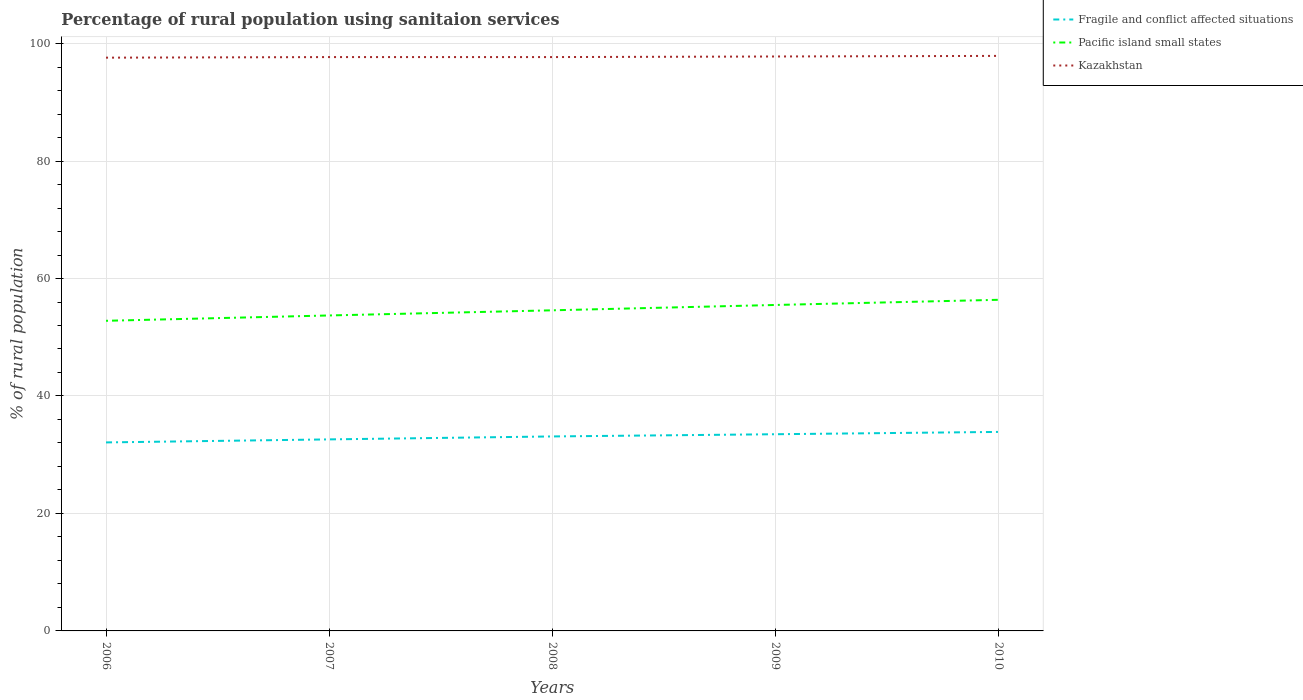Does the line corresponding to Pacific island small states intersect with the line corresponding to Fragile and conflict affected situations?
Keep it short and to the point. No. Is the number of lines equal to the number of legend labels?
Give a very brief answer. Yes. Across all years, what is the maximum percentage of rural population using sanitaion services in Kazakhstan?
Your answer should be compact. 97.6. In which year was the percentage of rural population using sanitaion services in Pacific island small states maximum?
Your response must be concise. 2006. What is the total percentage of rural population using sanitaion services in Fragile and conflict affected situations in the graph?
Provide a short and direct response. -0.5. What is the difference between the highest and the second highest percentage of rural population using sanitaion services in Fragile and conflict affected situations?
Your answer should be compact. 1.79. Is the percentage of rural population using sanitaion services in Fragile and conflict affected situations strictly greater than the percentage of rural population using sanitaion services in Kazakhstan over the years?
Ensure brevity in your answer.  Yes. What is the difference between two consecutive major ticks on the Y-axis?
Offer a terse response. 20. How many legend labels are there?
Make the answer very short. 3. What is the title of the graph?
Offer a very short reply. Percentage of rural population using sanitaion services. What is the label or title of the X-axis?
Your answer should be very brief. Years. What is the label or title of the Y-axis?
Offer a terse response. % of rural population. What is the % of rural population of Fragile and conflict affected situations in 2006?
Offer a terse response. 32.09. What is the % of rural population of Pacific island small states in 2006?
Offer a terse response. 52.8. What is the % of rural population of Kazakhstan in 2006?
Give a very brief answer. 97.6. What is the % of rural population in Fragile and conflict affected situations in 2007?
Ensure brevity in your answer.  32.61. What is the % of rural population of Pacific island small states in 2007?
Offer a very short reply. 53.71. What is the % of rural population of Kazakhstan in 2007?
Ensure brevity in your answer.  97.7. What is the % of rural population in Fragile and conflict affected situations in 2008?
Keep it short and to the point. 33.11. What is the % of rural population in Pacific island small states in 2008?
Provide a short and direct response. 54.59. What is the % of rural population in Kazakhstan in 2008?
Your answer should be very brief. 97.7. What is the % of rural population of Fragile and conflict affected situations in 2009?
Offer a terse response. 33.49. What is the % of rural population of Pacific island small states in 2009?
Ensure brevity in your answer.  55.5. What is the % of rural population of Kazakhstan in 2009?
Make the answer very short. 97.8. What is the % of rural population in Fragile and conflict affected situations in 2010?
Offer a very short reply. 33.88. What is the % of rural population of Pacific island small states in 2010?
Provide a short and direct response. 56.37. What is the % of rural population in Kazakhstan in 2010?
Provide a succinct answer. 97.9. Across all years, what is the maximum % of rural population in Fragile and conflict affected situations?
Ensure brevity in your answer.  33.88. Across all years, what is the maximum % of rural population in Pacific island small states?
Provide a succinct answer. 56.37. Across all years, what is the maximum % of rural population in Kazakhstan?
Make the answer very short. 97.9. Across all years, what is the minimum % of rural population of Fragile and conflict affected situations?
Your response must be concise. 32.09. Across all years, what is the minimum % of rural population of Pacific island small states?
Ensure brevity in your answer.  52.8. Across all years, what is the minimum % of rural population of Kazakhstan?
Provide a short and direct response. 97.6. What is the total % of rural population in Fragile and conflict affected situations in the graph?
Offer a very short reply. 165.19. What is the total % of rural population in Pacific island small states in the graph?
Your answer should be compact. 272.97. What is the total % of rural population in Kazakhstan in the graph?
Your answer should be compact. 488.7. What is the difference between the % of rural population in Fragile and conflict affected situations in 2006 and that in 2007?
Provide a short and direct response. -0.51. What is the difference between the % of rural population in Pacific island small states in 2006 and that in 2007?
Provide a short and direct response. -0.91. What is the difference between the % of rural population of Kazakhstan in 2006 and that in 2007?
Your response must be concise. -0.1. What is the difference between the % of rural population in Fragile and conflict affected situations in 2006 and that in 2008?
Your answer should be very brief. -1.02. What is the difference between the % of rural population in Pacific island small states in 2006 and that in 2008?
Give a very brief answer. -1.78. What is the difference between the % of rural population of Fragile and conflict affected situations in 2006 and that in 2009?
Your response must be concise. -1.39. What is the difference between the % of rural population in Pacific island small states in 2006 and that in 2009?
Keep it short and to the point. -2.69. What is the difference between the % of rural population in Fragile and conflict affected situations in 2006 and that in 2010?
Ensure brevity in your answer.  -1.79. What is the difference between the % of rural population in Pacific island small states in 2006 and that in 2010?
Your response must be concise. -3.57. What is the difference between the % of rural population of Fragile and conflict affected situations in 2007 and that in 2008?
Keep it short and to the point. -0.5. What is the difference between the % of rural population of Pacific island small states in 2007 and that in 2008?
Your response must be concise. -0.88. What is the difference between the % of rural population of Kazakhstan in 2007 and that in 2008?
Ensure brevity in your answer.  0. What is the difference between the % of rural population of Fragile and conflict affected situations in 2007 and that in 2009?
Provide a short and direct response. -0.88. What is the difference between the % of rural population in Pacific island small states in 2007 and that in 2009?
Offer a terse response. -1.79. What is the difference between the % of rural population in Fragile and conflict affected situations in 2007 and that in 2010?
Ensure brevity in your answer.  -1.27. What is the difference between the % of rural population of Pacific island small states in 2007 and that in 2010?
Provide a succinct answer. -2.67. What is the difference between the % of rural population of Fragile and conflict affected situations in 2008 and that in 2009?
Give a very brief answer. -0.38. What is the difference between the % of rural population of Pacific island small states in 2008 and that in 2009?
Ensure brevity in your answer.  -0.91. What is the difference between the % of rural population in Fragile and conflict affected situations in 2008 and that in 2010?
Provide a short and direct response. -0.77. What is the difference between the % of rural population of Pacific island small states in 2008 and that in 2010?
Offer a terse response. -1.79. What is the difference between the % of rural population of Kazakhstan in 2008 and that in 2010?
Provide a short and direct response. -0.2. What is the difference between the % of rural population in Fragile and conflict affected situations in 2009 and that in 2010?
Ensure brevity in your answer.  -0.4. What is the difference between the % of rural population of Pacific island small states in 2009 and that in 2010?
Your response must be concise. -0.88. What is the difference between the % of rural population of Kazakhstan in 2009 and that in 2010?
Ensure brevity in your answer.  -0.1. What is the difference between the % of rural population of Fragile and conflict affected situations in 2006 and the % of rural population of Pacific island small states in 2007?
Offer a very short reply. -21.62. What is the difference between the % of rural population in Fragile and conflict affected situations in 2006 and the % of rural population in Kazakhstan in 2007?
Ensure brevity in your answer.  -65.61. What is the difference between the % of rural population in Pacific island small states in 2006 and the % of rural population in Kazakhstan in 2007?
Offer a terse response. -44.9. What is the difference between the % of rural population in Fragile and conflict affected situations in 2006 and the % of rural population in Pacific island small states in 2008?
Give a very brief answer. -22.49. What is the difference between the % of rural population of Fragile and conflict affected situations in 2006 and the % of rural population of Kazakhstan in 2008?
Provide a short and direct response. -65.61. What is the difference between the % of rural population of Pacific island small states in 2006 and the % of rural population of Kazakhstan in 2008?
Provide a short and direct response. -44.9. What is the difference between the % of rural population in Fragile and conflict affected situations in 2006 and the % of rural population in Pacific island small states in 2009?
Give a very brief answer. -23.4. What is the difference between the % of rural population of Fragile and conflict affected situations in 2006 and the % of rural population of Kazakhstan in 2009?
Ensure brevity in your answer.  -65.71. What is the difference between the % of rural population in Pacific island small states in 2006 and the % of rural population in Kazakhstan in 2009?
Make the answer very short. -45. What is the difference between the % of rural population in Fragile and conflict affected situations in 2006 and the % of rural population in Pacific island small states in 2010?
Your response must be concise. -24.28. What is the difference between the % of rural population of Fragile and conflict affected situations in 2006 and the % of rural population of Kazakhstan in 2010?
Give a very brief answer. -65.81. What is the difference between the % of rural population of Pacific island small states in 2006 and the % of rural population of Kazakhstan in 2010?
Make the answer very short. -45.1. What is the difference between the % of rural population in Fragile and conflict affected situations in 2007 and the % of rural population in Pacific island small states in 2008?
Make the answer very short. -21.98. What is the difference between the % of rural population of Fragile and conflict affected situations in 2007 and the % of rural population of Kazakhstan in 2008?
Provide a succinct answer. -65.09. What is the difference between the % of rural population in Pacific island small states in 2007 and the % of rural population in Kazakhstan in 2008?
Your response must be concise. -43.99. What is the difference between the % of rural population of Fragile and conflict affected situations in 2007 and the % of rural population of Pacific island small states in 2009?
Provide a short and direct response. -22.89. What is the difference between the % of rural population in Fragile and conflict affected situations in 2007 and the % of rural population in Kazakhstan in 2009?
Provide a short and direct response. -65.19. What is the difference between the % of rural population of Pacific island small states in 2007 and the % of rural population of Kazakhstan in 2009?
Offer a terse response. -44.09. What is the difference between the % of rural population in Fragile and conflict affected situations in 2007 and the % of rural population in Pacific island small states in 2010?
Keep it short and to the point. -23.77. What is the difference between the % of rural population of Fragile and conflict affected situations in 2007 and the % of rural population of Kazakhstan in 2010?
Ensure brevity in your answer.  -65.29. What is the difference between the % of rural population of Pacific island small states in 2007 and the % of rural population of Kazakhstan in 2010?
Offer a very short reply. -44.19. What is the difference between the % of rural population in Fragile and conflict affected situations in 2008 and the % of rural population in Pacific island small states in 2009?
Your response must be concise. -22.38. What is the difference between the % of rural population in Fragile and conflict affected situations in 2008 and the % of rural population in Kazakhstan in 2009?
Offer a very short reply. -64.69. What is the difference between the % of rural population in Pacific island small states in 2008 and the % of rural population in Kazakhstan in 2009?
Offer a very short reply. -43.21. What is the difference between the % of rural population in Fragile and conflict affected situations in 2008 and the % of rural population in Pacific island small states in 2010?
Your answer should be very brief. -23.26. What is the difference between the % of rural population in Fragile and conflict affected situations in 2008 and the % of rural population in Kazakhstan in 2010?
Provide a succinct answer. -64.79. What is the difference between the % of rural population in Pacific island small states in 2008 and the % of rural population in Kazakhstan in 2010?
Provide a succinct answer. -43.31. What is the difference between the % of rural population of Fragile and conflict affected situations in 2009 and the % of rural population of Pacific island small states in 2010?
Keep it short and to the point. -22.89. What is the difference between the % of rural population of Fragile and conflict affected situations in 2009 and the % of rural population of Kazakhstan in 2010?
Provide a succinct answer. -64.41. What is the difference between the % of rural population of Pacific island small states in 2009 and the % of rural population of Kazakhstan in 2010?
Make the answer very short. -42.4. What is the average % of rural population in Fragile and conflict affected situations per year?
Your response must be concise. 33.04. What is the average % of rural population of Pacific island small states per year?
Offer a very short reply. 54.59. What is the average % of rural population in Kazakhstan per year?
Keep it short and to the point. 97.74. In the year 2006, what is the difference between the % of rural population in Fragile and conflict affected situations and % of rural population in Pacific island small states?
Your answer should be very brief. -20.71. In the year 2006, what is the difference between the % of rural population of Fragile and conflict affected situations and % of rural population of Kazakhstan?
Make the answer very short. -65.51. In the year 2006, what is the difference between the % of rural population in Pacific island small states and % of rural population in Kazakhstan?
Provide a succinct answer. -44.8. In the year 2007, what is the difference between the % of rural population of Fragile and conflict affected situations and % of rural population of Pacific island small states?
Ensure brevity in your answer.  -21.1. In the year 2007, what is the difference between the % of rural population in Fragile and conflict affected situations and % of rural population in Kazakhstan?
Offer a very short reply. -65.09. In the year 2007, what is the difference between the % of rural population in Pacific island small states and % of rural population in Kazakhstan?
Keep it short and to the point. -43.99. In the year 2008, what is the difference between the % of rural population of Fragile and conflict affected situations and % of rural population of Pacific island small states?
Offer a terse response. -21.47. In the year 2008, what is the difference between the % of rural population of Fragile and conflict affected situations and % of rural population of Kazakhstan?
Ensure brevity in your answer.  -64.59. In the year 2008, what is the difference between the % of rural population of Pacific island small states and % of rural population of Kazakhstan?
Provide a succinct answer. -43.11. In the year 2009, what is the difference between the % of rural population of Fragile and conflict affected situations and % of rural population of Pacific island small states?
Provide a short and direct response. -22.01. In the year 2009, what is the difference between the % of rural population of Fragile and conflict affected situations and % of rural population of Kazakhstan?
Your response must be concise. -64.31. In the year 2009, what is the difference between the % of rural population of Pacific island small states and % of rural population of Kazakhstan?
Your answer should be very brief. -42.3. In the year 2010, what is the difference between the % of rural population of Fragile and conflict affected situations and % of rural population of Pacific island small states?
Your response must be concise. -22.49. In the year 2010, what is the difference between the % of rural population of Fragile and conflict affected situations and % of rural population of Kazakhstan?
Your answer should be very brief. -64.02. In the year 2010, what is the difference between the % of rural population in Pacific island small states and % of rural population in Kazakhstan?
Your response must be concise. -41.53. What is the ratio of the % of rural population of Fragile and conflict affected situations in 2006 to that in 2007?
Your answer should be very brief. 0.98. What is the ratio of the % of rural population of Pacific island small states in 2006 to that in 2007?
Provide a short and direct response. 0.98. What is the ratio of the % of rural population in Kazakhstan in 2006 to that in 2007?
Make the answer very short. 1. What is the ratio of the % of rural population of Fragile and conflict affected situations in 2006 to that in 2008?
Provide a short and direct response. 0.97. What is the ratio of the % of rural population of Pacific island small states in 2006 to that in 2008?
Give a very brief answer. 0.97. What is the ratio of the % of rural population of Kazakhstan in 2006 to that in 2008?
Provide a succinct answer. 1. What is the ratio of the % of rural population in Fragile and conflict affected situations in 2006 to that in 2009?
Offer a terse response. 0.96. What is the ratio of the % of rural population in Pacific island small states in 2006 to that in 2009?
Your answer should be compact. 0.95. What is the ratio of the % of rural population of Fragile and conflict affected situations in 2006 to that in 2010?
Give a very brief answer. 0.95. What is the ratio of the % of rural population in Pacific island small states in 2006 to that in 2010?
Provide a succinct answer. 0.94. What is the ratio of the % of rural population of Pacific island small states in 2007 to that in 2008?
Make the answer very short. 0.98. What is the ratio of the % of rural population of Kazakhstan in 2007 to that in 2008?
Provide a short and direct response. 1. What is the ratio of the % of rural population in Fragile and conflict affected situations in 2007 to that in 2009?
Your answer should be very brief. 0.97. What is the ratio of the % of rural population in Pacific island small states in 2007 to that in 2009?
Provide a succinct answer. 0.97. What is the ratio of the % of rural population in Kazakhstan in 2007 to that in 2009?
Give a very brief answer. 1. What is the ratio of the % of rural population of Fragile and conflict affected situations in 2007 to that in 2010?
Offer a terse response. 0.96. What is the ratio of the % of rural population of Pacific island small states in 2007 to that in 2010?
Give a very brief answer. 0.95. What is the ratio of the % of rural population of Kazakhstan in 2007 to that in 2010?
Offer a very short reply. 1. What is the ratio of the % of rural population in Pacific island small states in 2008 to that in 2009?
Offer a terse response. 0.98. What is the ratio of the % of rural population in Kazakhstan in 2008 to that in 2009?
Keep it short and to the point. 1. What is the ratio of the % of rural population in Fragile and conflict affected situations in 2008 to that in 2010?
Provide a short and direct response. 0.98. What is the ratio of the % of rural population in Pacific island small states in 2008 to that in 2010?
Give a very brief answer. 0.97. What is the ratio of the % of rural population of Kazakhstan in 2008 to that in 2010?
Offer a terse response. 1. What is the ratio of the % of rural population of Fragile and conflict affected situations in 2009 to that in 2010?
Ensure brevity in your answer.  0.99. What is the ratio of the % of rural population in Pacific island small states in 2009 to that in 2010?
Provide a short and direct response. 0.98. What is the difference between the highest and the second highest % of rural population in Fragile and conflict affected situations?
Keep it short and to the point. 0.4. What is the difference between the highest and the second highest % of rural population in Pacific island small states?
Your answer should be very brief. 0.88. What is the difference between the highest and the second highest % of rural population of Kazakhstan?
Ensure brevity in your answer.  0.1. What is the difference between the highest and the lowest % of rural population of Fragile and conflict affected situations?
Keep it short and to the point. 1.79. What is the difference between the highest and the lowest % of rural population of Pacific island small states?
Your answer should be compact. 3.57. 